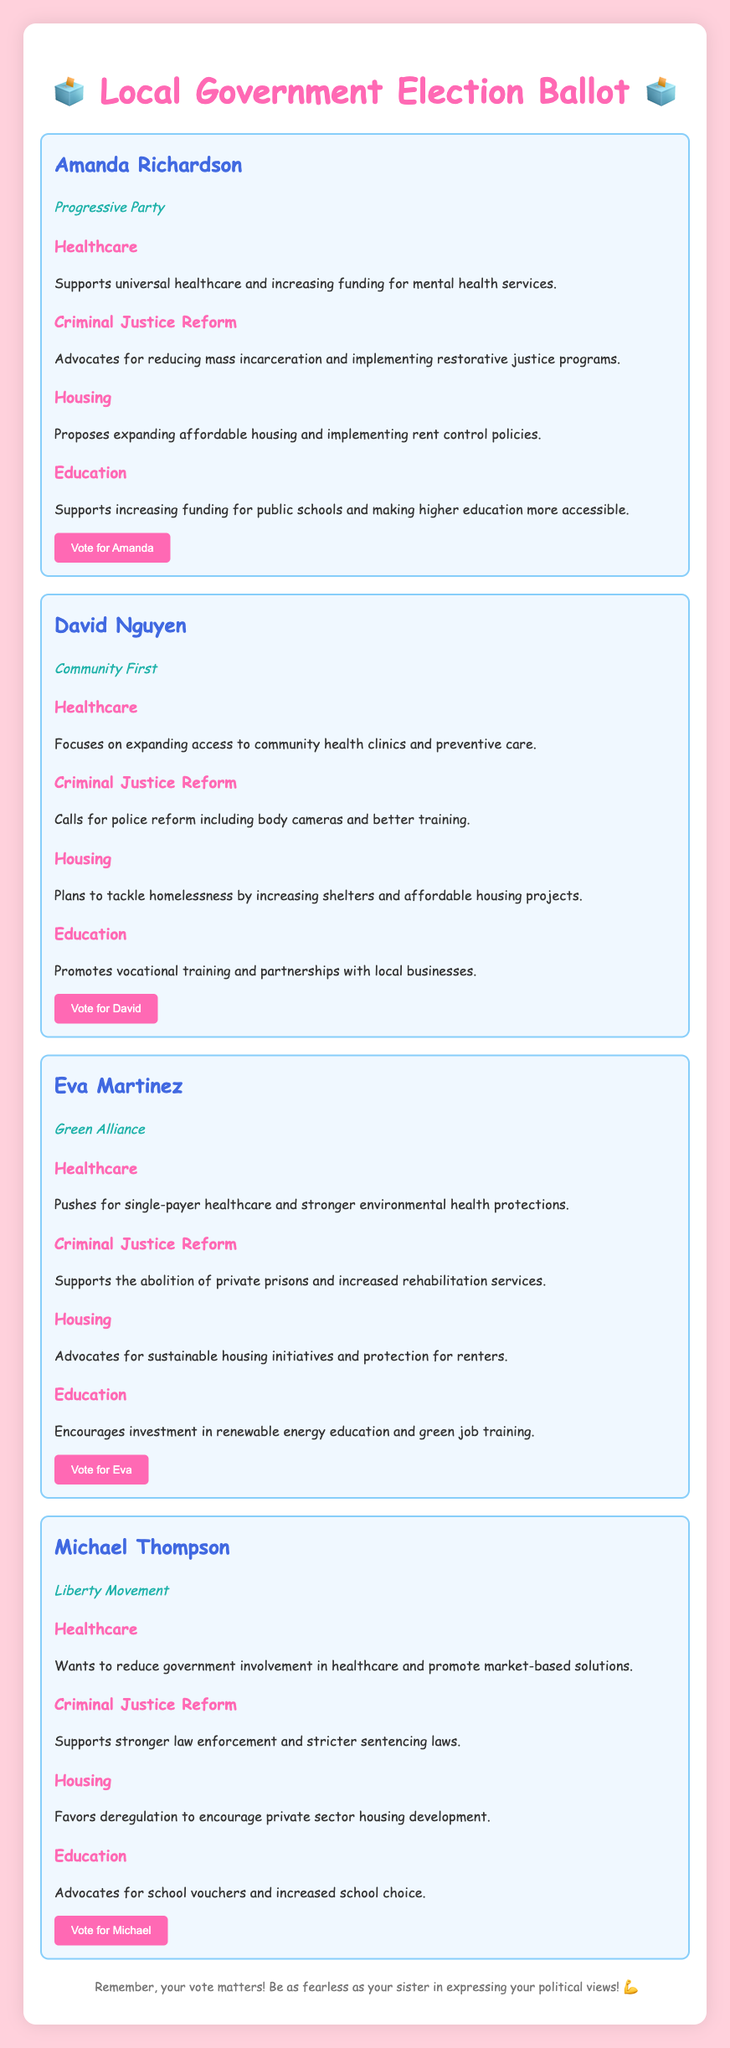What is the name of the first candidate? The first candidate listed in the document is Amanda Richardson.
Answer: Amanda Richardson What political party does David Nguyen represent? David Nguyen is associated with the Community First party.
Answer: Community First How many candidates are there in total? The document presents four candidates for the local government election.
Answer: Four Which candidate supports single-payer healthcare? Eva Martinez, as part of her healthcare stance, pushes for single-payer healthcare.
Answer: Eva Martinez What stance does Michael Thompson take on criminal justice reform? Michael Thompson supports stronger law enforcement and stricter sentencing laws for criminal justice reform.
Answer: Stronger law enforcement What education initiative does Amanda Richardson advocate for? Amanda Richardson supports increasing funding for public schools as part of her educational stance.
Answer: Increasing funding for public schools Which candidate plans to tackle homelessness? David Nguyen plans to address homelessness by increasing shelters and affordable housing projects.
Answer: David Nguyen What color is the background of the document? The background color of the document is a light pink shade represented by the hex code #ffd1dc.
Answer: Light pink What button text appears for Eva Martinez? The button text for Eva Martinez encourages users to vote for her.
Answer: Vote for Eva 